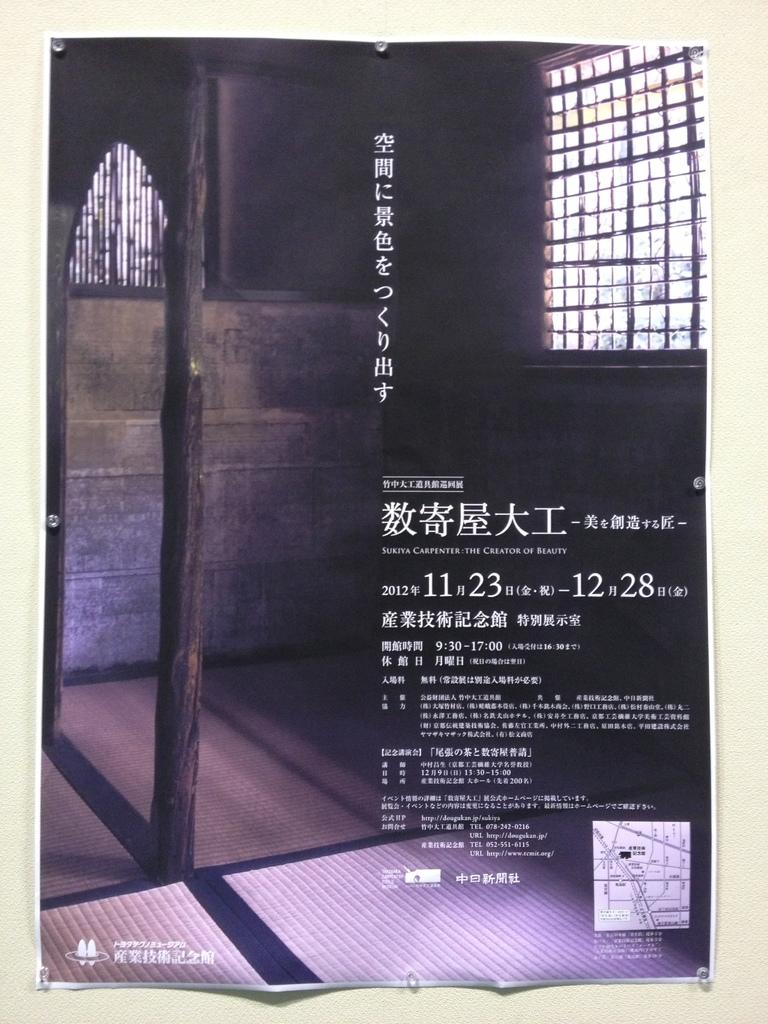How many windows can be seen in the image? There are two windows in the image. What type of floor covering is visible in the image? Floor mats are visible in the image. What material is the wooden log made of? The wooden log is made of wood. What is present on the image that suggests written content? There is something written on the image. How many kittens are playing on the side of the wooden log in the image? There are no kittens present in the image, and the wooden log is not depicted as having any side. What scientific theory is being discussed in the written content on the image? There is no indication of any scientific theory being discussed in the written content on the image. 